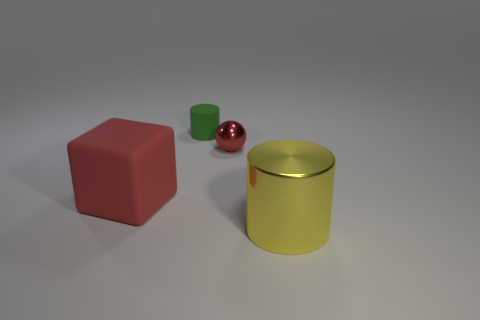Add 4 large brown metal cylinders. How many objects exist? 8 Subtract all balls. How many objects are left? 3 Add 4 small red balls. How many small red balls are left? 5 Add 3 tiny yellow shiny objects. How many tiny yellow shiny objects exist? 3 Subtract 0 yellow balls. How many objects are left? 4 Subtract all large red blocks. Subtract all yellow cylinders. How many objects are left? 2 